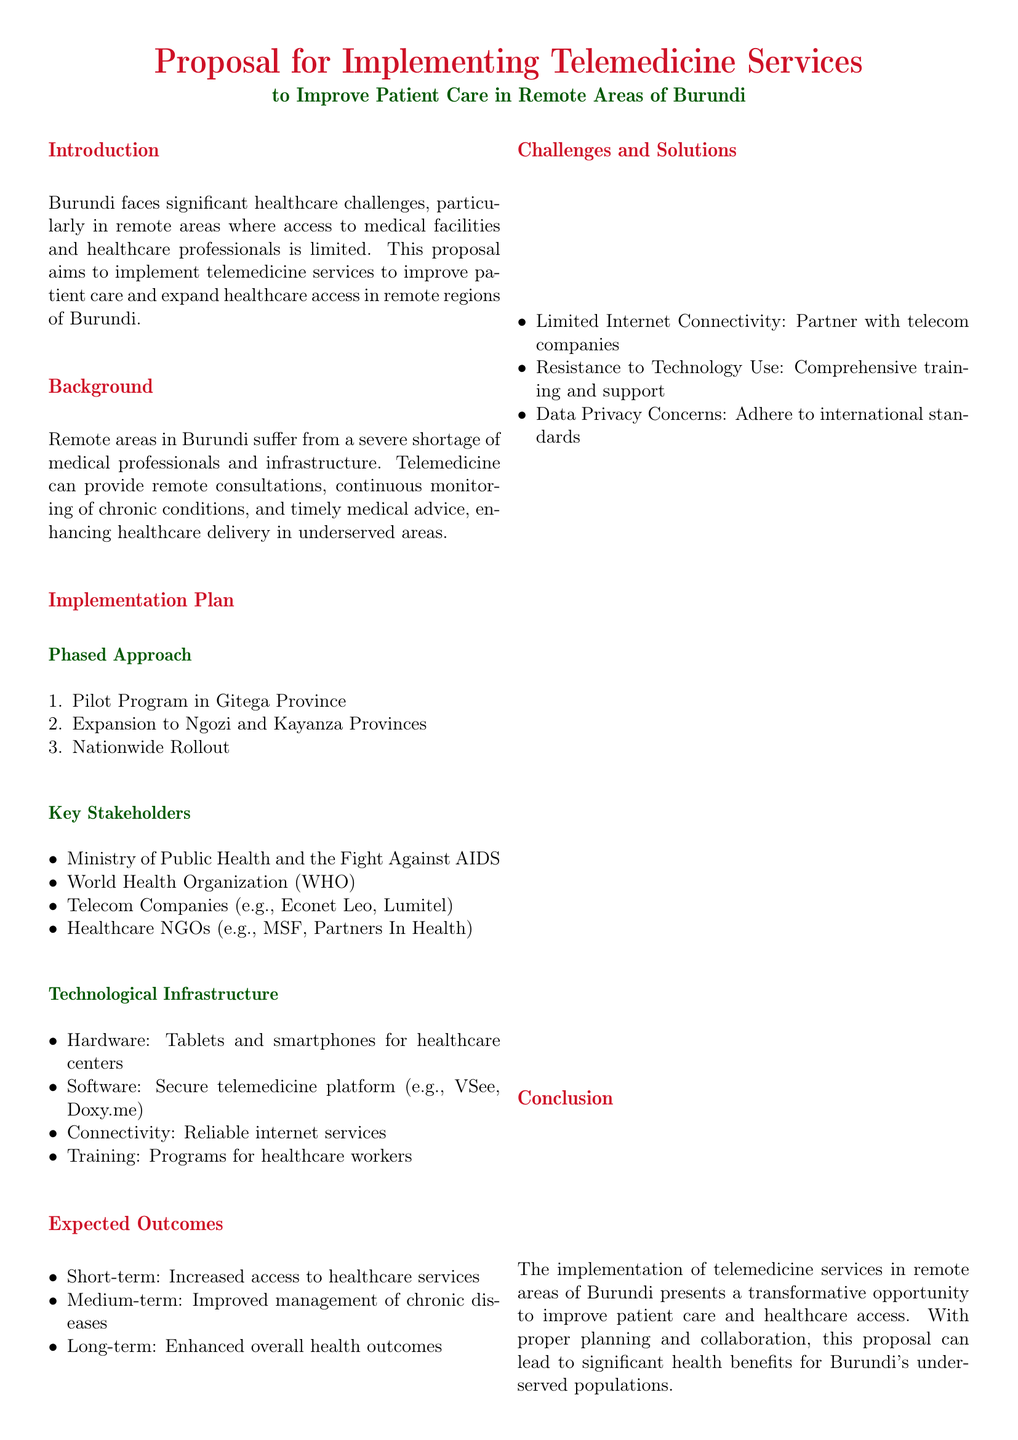What is the main goal of the proposal? The main goal of the proposal is to implement telemedicine services to improve patient care and expand healthcare access in remote regions of Burundi.
Answer: Improve patient care What is the first phase of the implementation plan? The first phase of the implementation plan is the pilot program in Gitega Province.
Answer: Pilot Program in Gitega Province Which two provinces will the program expand to after the pilot? The program will expand to Ngozi and Kayanza Provinces after the pilot.
Answer: Ngozi and Kayanza Provinces What type of platform is proposed for telemedicine services? The proposal mentions a secure telemedicine platform, specifically VSee or Doxy.me.
Answer: VSee, Doxy.me Which stakeholders are listed in the implementation plan? Key stakeholders include the Ministry of Public Health and the Fight Against AIDS, WHO, telecom companies, and healthcare NGOs.
Answer: Ministry of Public Health and the Fight Against AIDS, WHO, telecom companies, healthcare NGOs What is one of the expected short-term outcomes of implementing telemedicine? One expected short-term outcome is increased access to healthcare services.
Answer: Increased access to healthcare services What is a challenge mentioned related to internet connectivity? The challenge mentioned is limited internet connectivity.
Answer: Limited Internet Connectivity What is one solution proposed for resistance to technology use? A proposed solution for resistance to technology use is comprehensive training and support.
Answer: Comprehensive training and support What is the primary call to action in the document? The primary call to action is for stakeholders to support and commit to the initiative.
Answer: Support and commitment of all stakeholders 